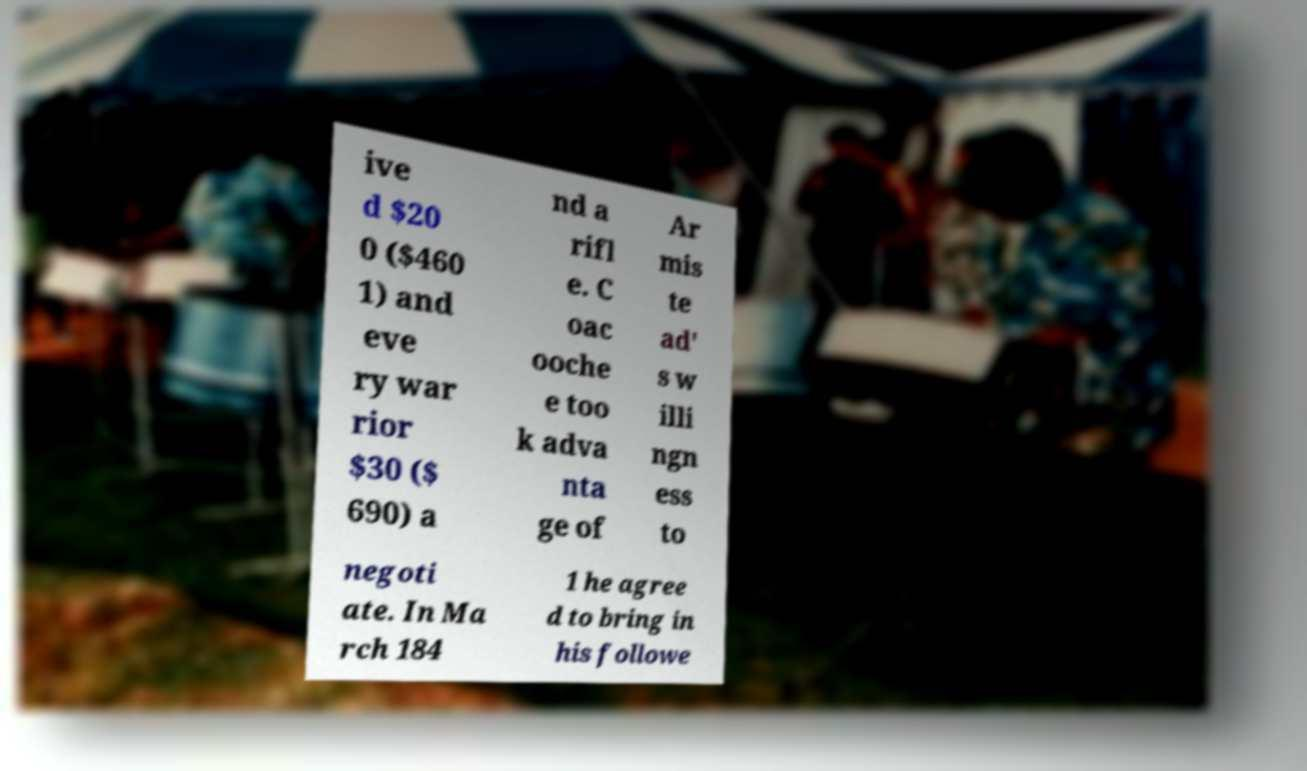Please identify and transcribe the text found in this image. ive d $20 0 ($460 1) and eve ry war rior $30 ($ 690) a nd a rifl e. C oac ooche e too k adva nta ge of Ar mis te ad' s w illi ngn ess to negoti ate. In Ma rch 184 1 he agree d to bring in his followe 